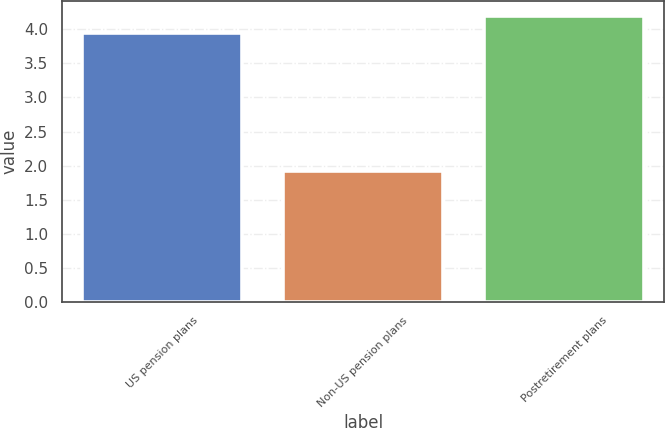Convert chart. <chart><loc_0><loc_0><loc_500><loc_500><bar_chart><fcel>US pension plans<fcel>Non-US pension plans<fcel>Postretirement plans<nl><fcel>3.95<fcel>1.92<fcel>4.2<nl></chart> 